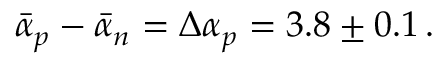<formula> <loc_0><loc_0><loc_500><loc_500>\bar { \alpha } _ { p } - \bar { \alpha } _ { n } = \Delta \alpha _ { p } = 3 . 8 \pm 0 . 1 \, .</formula> 